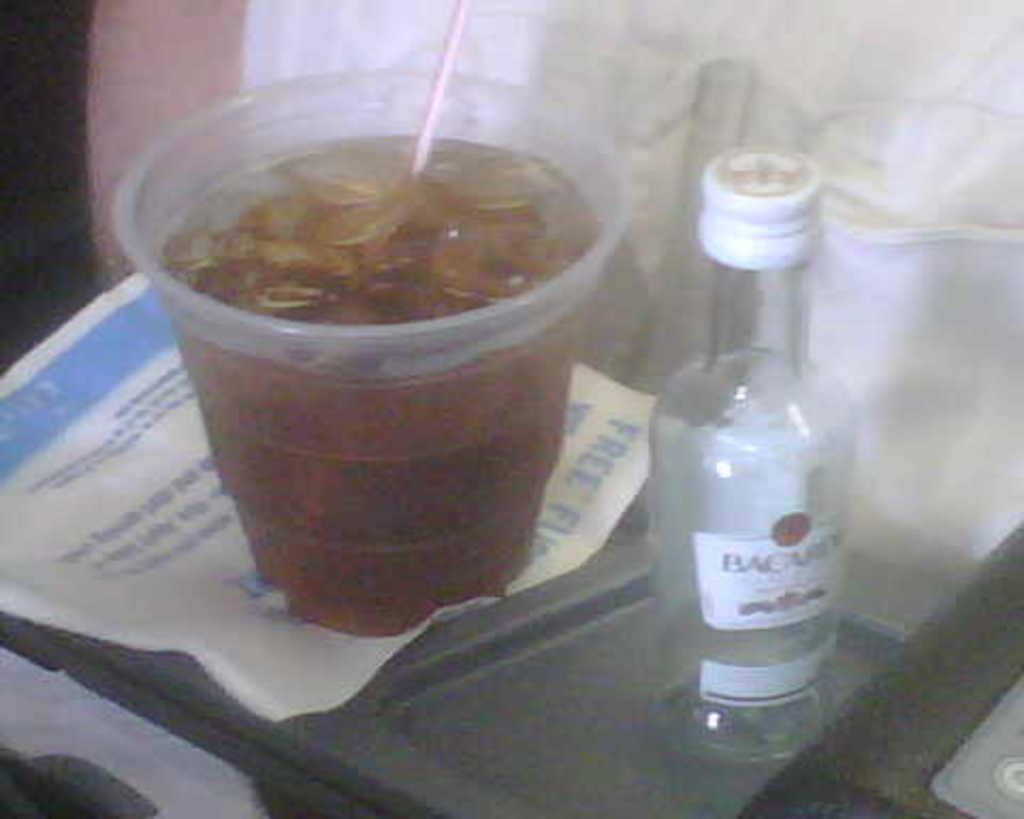What type of container is visible in the image? There is a glass in the image. What other type of container can be seen in the image? There is a bottle in the image. What is the order of the containers from left to right in the image? There is no information provided about the position of the containers in relation to each other, so it is impossible to determine the order from left to right. 